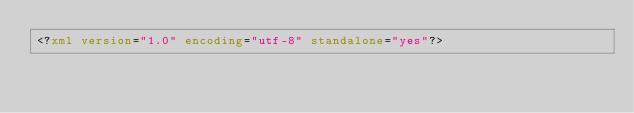<code> <loc_0><loc_0><loc_500><loc_500><_XML_><?xml version="1.0" encoding="utf-8" standalone="yes"?></code> 